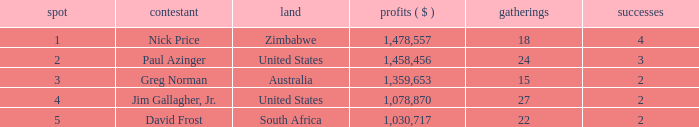How many events are in South Africa? 22.0. 